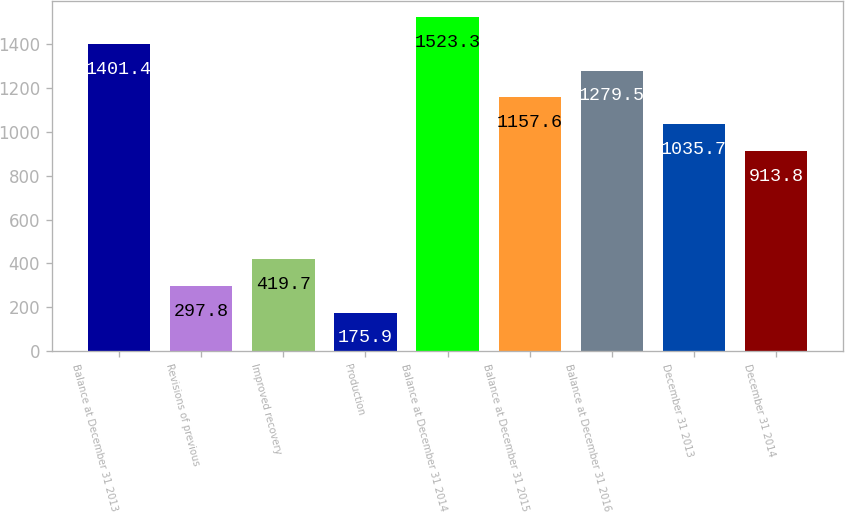Convert chart to OTSL. <chart><loc_0><loc_0><loc_500><loc_500><bar_chart><fcel>Balance at December 31 2013<fcel>Revisions of previous<fcel>Improved recovery<fcel>Production<fcel>Balance at December 31 2014<fcel>Balance at December 31 2015<fcel>Balance at December 31 2016<fcel>December 31 2013<fcel>December 31 2014<nl><fcel>1401.4<fcel>297.8<fcel>419.7<fcel>175.9<fcel>1523.3<fcel>1157.6<fcel>1279.5<fcel>1035.7<fcel>913.8<nl></chart> 